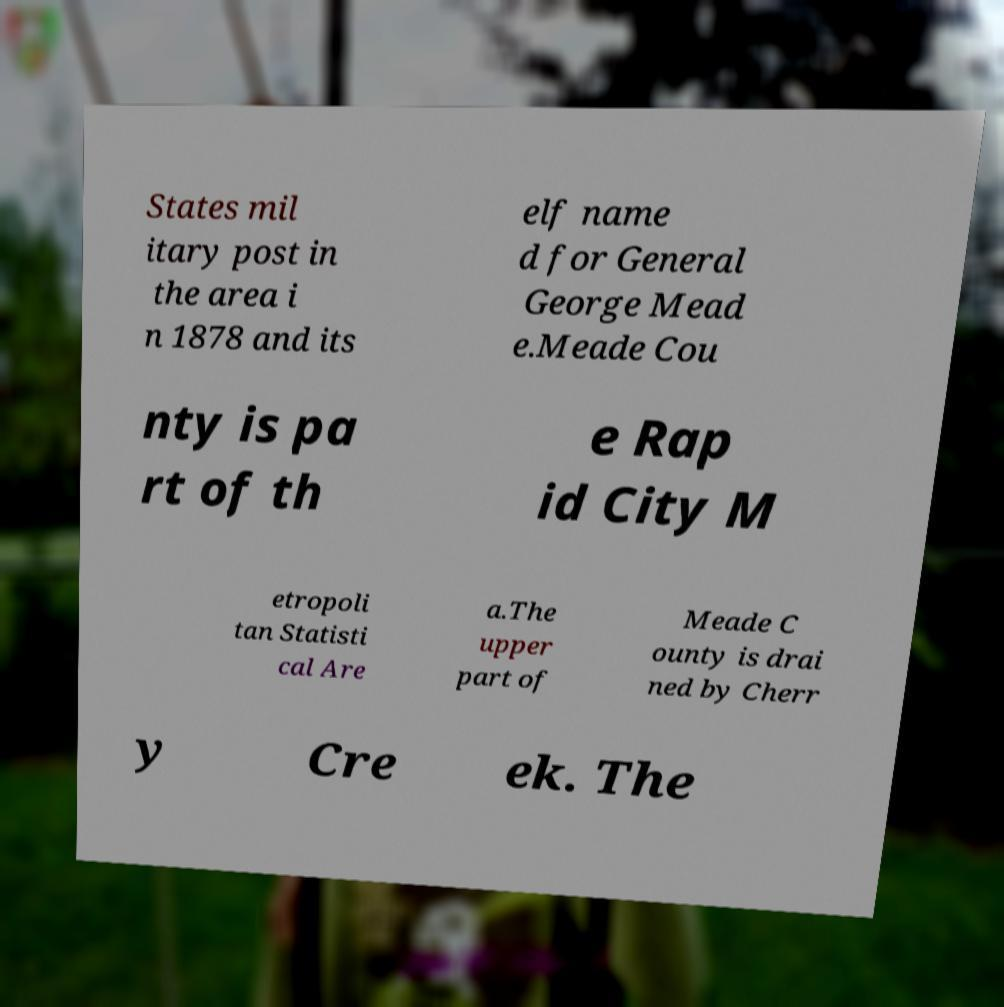I need the written content from this picture converted into text. Can you do that? States mil itary post in the area i n 1878 and its elf name d for General George Mead e.Meade Cou nty is pa rt of th e Rap id City M etropoli tan Statisti cal Are a.The upper part of Meade C ounty is drai ned by Cherr y Cre ek. The 